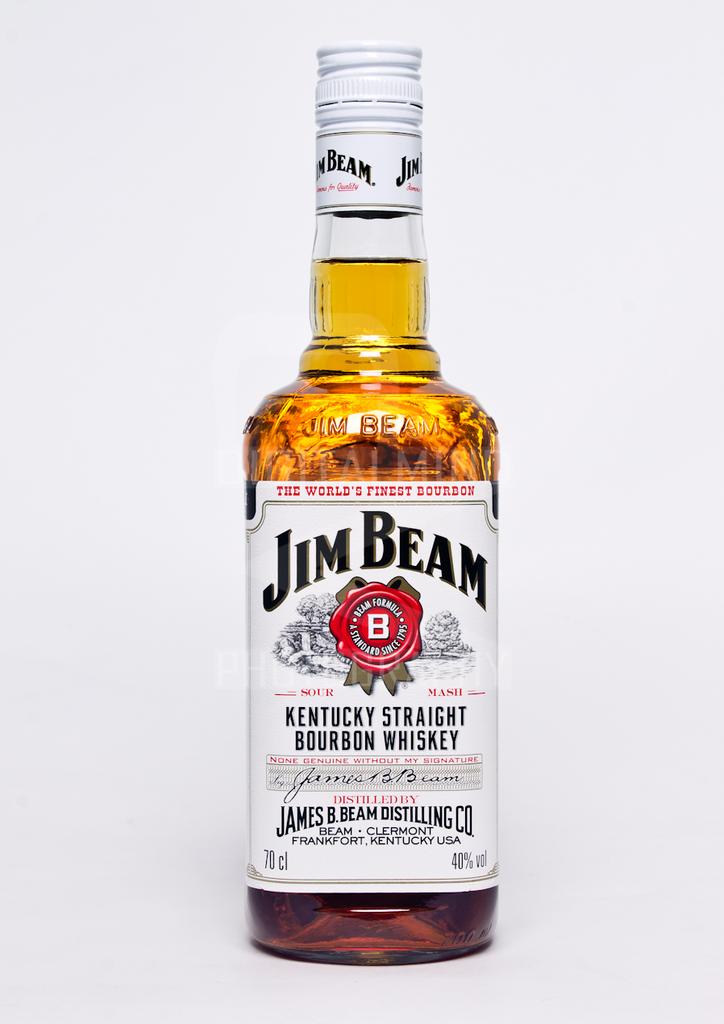What state is this whiskey made in?
Your answer should be very brief. Kentucky. What brand of whiskey is this?
Offer a very short reply. Jim beam. 